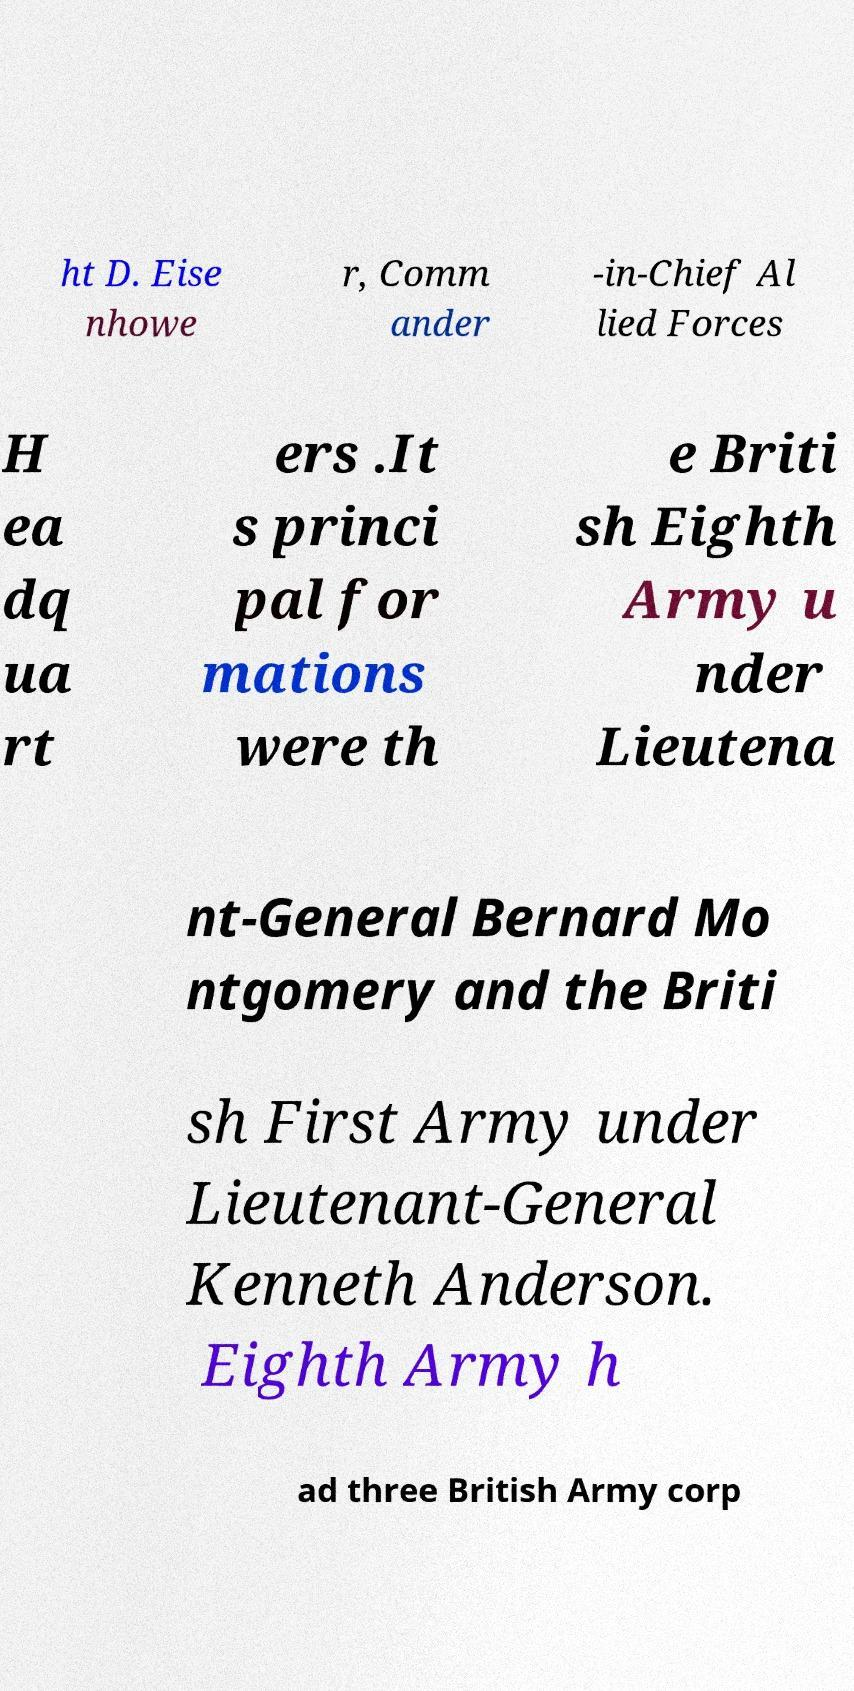There's text embedded in this image that I need extracted. Can you transcribe it verbatim? ht D. Eise nhowe r, Comm ander -in-Chief Al lied Forces H ea dq ua rt ers .It s princi pal for mations were th e Briti sh Eighth Army u nder Lieutena nt-General Bernard Mo ntgomery and the Briti sh First Army under Lieutenant-General Kenneth Anderson. Eighth Army h ad three British Army corp 